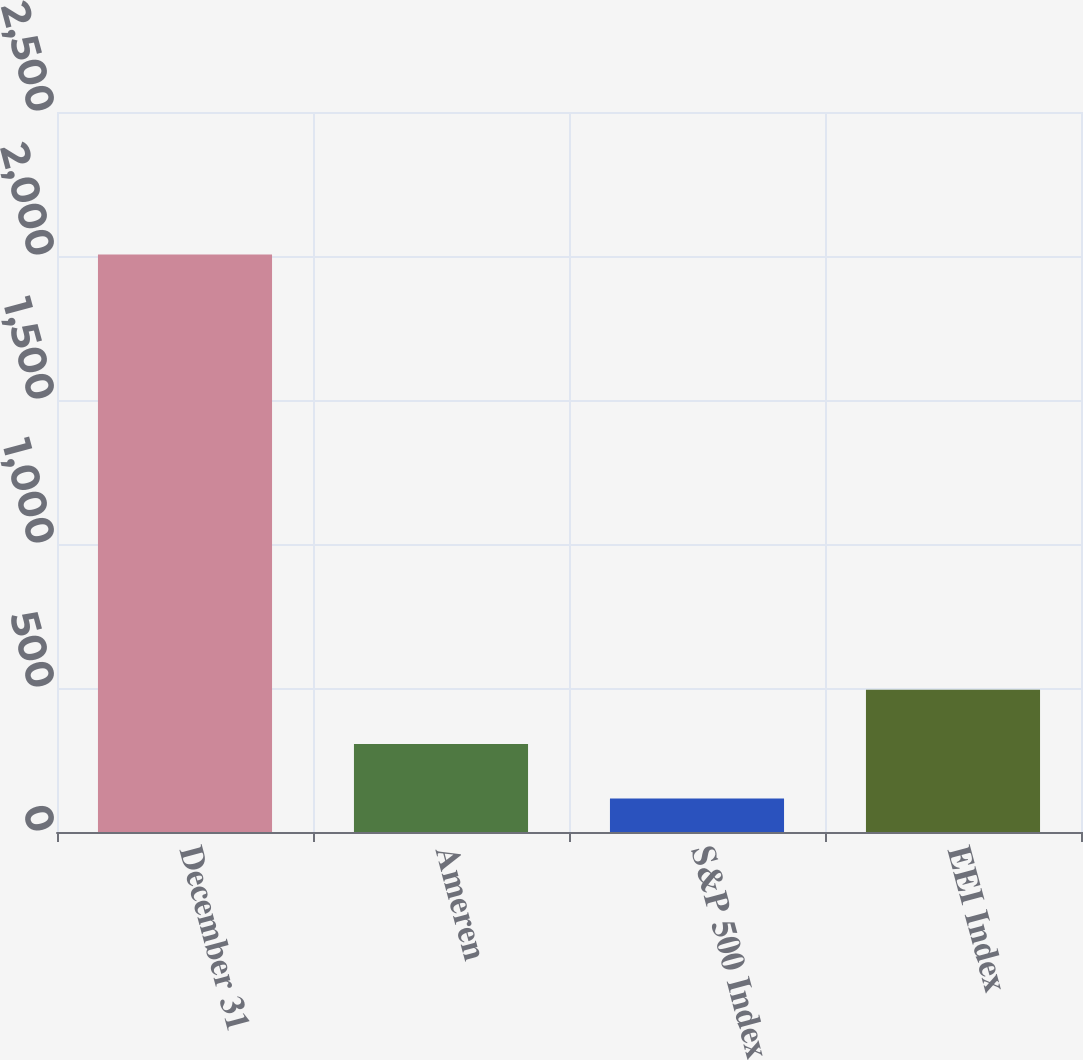Convert chart to OTSL. <chart><loc_0><loc_0><loc_500><loc_500><bar_chart><fcel>December 31<fcel>Ameren<fcel>S&P 500 Index<fcel>EEI Index<nl><fcel>2005<fcel>305.19<fcel>116.32<fcel>494.06<nl></chart> 